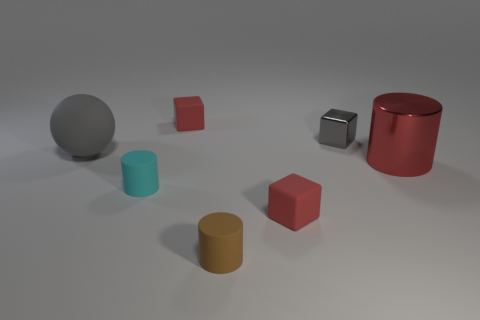There is a rubber ball that is the same color as the tiny metallic cube; what is its size?
Offer a terse response. Large. There is a large thing that is the same color as the tiny metal thing; what is its material?
Your answer should be very brief. Rubber. Is the shape of the red metallic object the same as the tiny gray metal thing?
Offer a terse response. No. What size is the red rubber block to the left of the small brown matte object?
Ensure brevity in your answer.  Small. Are there any other matte things of the same color as the big rubber object?
Offer a terse response. No. There is a rubber block behind the gray rubber object; is its size the same as the tiny cyan rubber object?
Offer a terse response. Yes. The matte sphere has what color?
Make the answer very short. Gray. There is a metallic thing behind the big rubber object that is left of the shiny cube; what color is it?
Your answer should be compact. Gray. Are there any tiny cyan blocks made of the same material as the big gray sphere?
Your answer should be compact. No. What material is the tiny cylinder that is on the right side of the small red object that is behind the red cylinder?
Give a very brief answer. Rubber. 